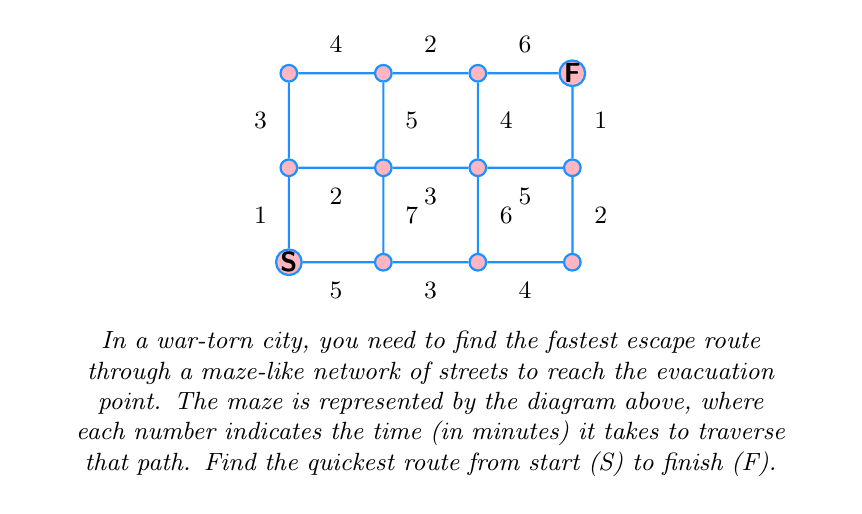Teach me how to tackle this problem. To solve this problem, we'll use Dijkstra's algorithm to find the shortest path from start to finish. Let's go through the steps:

1) Initialize:
   - Set distance to start (S) as 0
   - Set distances to all other points as infinity
   - Mark all points as unvisited

2) For the current point (starting with S), consider all unvisited neighbors and calculate their tentative distances.
   
3) When we've considered all neighbors, mark the current point as visited. A visited point will not be checked again.
   
4) If the destination point (F) has been marked visited, we have found the shortest path.
   
5) Otherwise, select the unvisited point with the smallest tentative distance, and repeat from step 2.

Following this algorithm:

- From S: 
  - To B: 5
  - To E: 1 (shortest)
- From E:
  - To I: 1 + 3 = 4
  - To F: 1 + 2 = 3 (shortest)
- From F:
  - To B: 3 + 7 = 10
  - To J: 3 + 5 = 8
  - To G: 3 + 3 = 6 (shortest)
- From G:
  - To C: 6 + 6 = 12
  - To K: 6 + 4 = 10
  - To H: 6 + 5 = 11 (shortest)
- From H:
  - To D: 11 + 2 = 13
  - To L (F): 11 + 1 = 12 (destination reached)

The shortest path is S -> E -> F -> G -> H -> L, with a total time of 12 minutes.
Answer: 12 minutes 